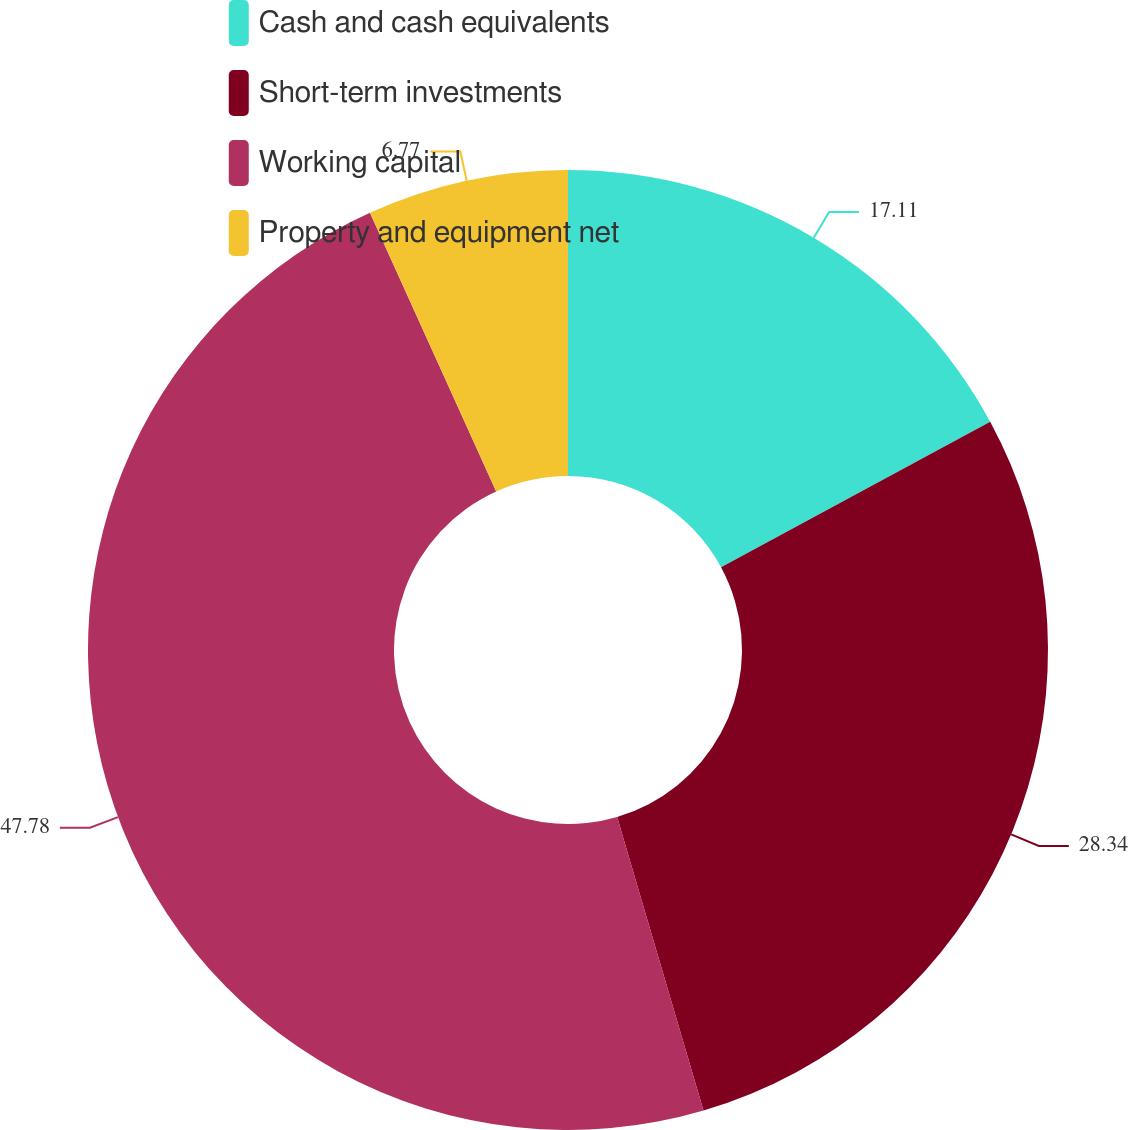Convert chart. <chart><loc_0><loc_0><loc_500><loc_500><pie_chart><fcel>Cash and cash equivalents<fcel>Short-term investments<fcel>Working capital<fcel>Property and equipment net<nl><fcel>17.11%<fcel>28.34%<fcel>47.79%<fcel>6.77%<nl></chart> 